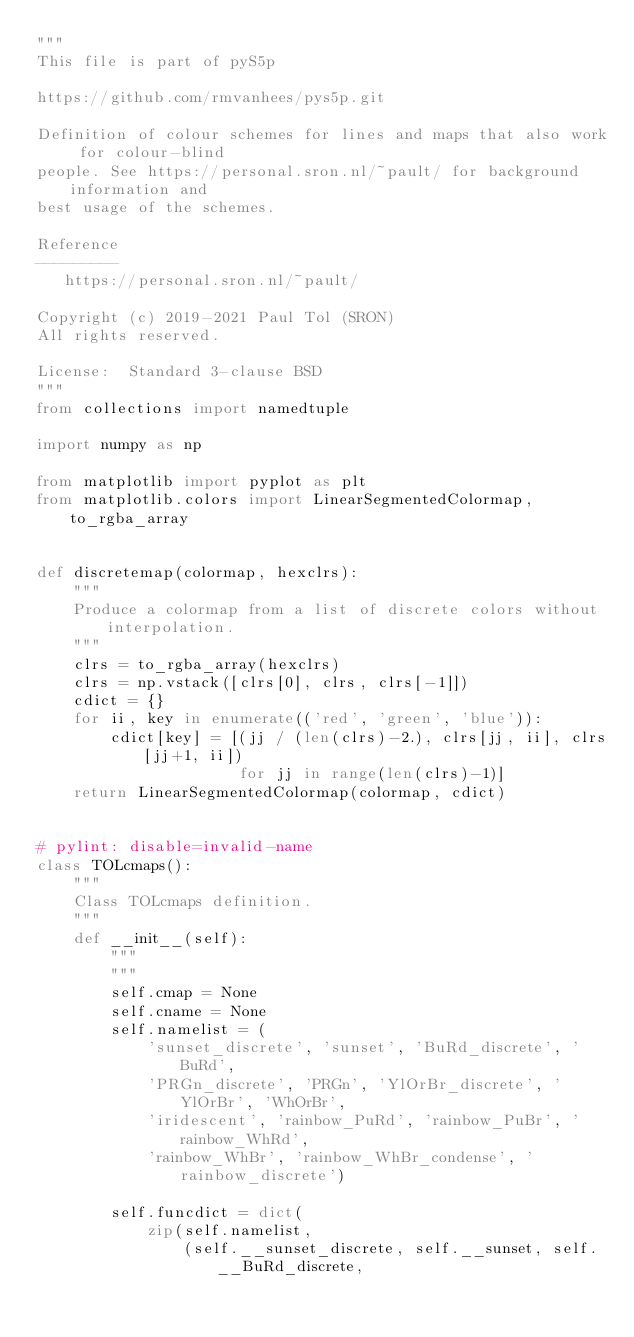Convert code to text. <code><loc_0><loc_0><loc_500><loc_500><_Python_>"""
This file is part of pyS5p

https://github.com/rmvanhees/pys5p.git

Definition of colour schemes for lines and maps that also work for colour-blind
people. See https://personal.sron.nl/~pault/ for background information and
best usage of the schemes.

Reference
---------
   https://personal.sron.nl/~pault/

Copyright (c) 2019-2021 Paul Tol (SRON)
All rights reserved.

License:  Standard 3-clause BSD
"""
from collections import namedtuple

import numpy as np

from matplotlib import pyplot as plt
from matplotlib.colors import LinearSegmentedColormap, to_rgba_array


def discretemap(colormap, hexclrs):
    """
    Produce a colormap from a list of discrete colors without interpolation.
    """
    clrs = to_rgba_array(hexclrs)
    clrs = np.vstack([clrs[0], clrs, clrs[-1]])
    cdict = {}
    for ii, key in enumerate(('red', 'green', 'blue')):
        cdict[key] = [(jj / (len(clrs)-2.), clrs[jj, ii], clrs[jj+1, ii])
                      for jj in range(len(clrs)-1)]
    return LinearSegmentedColormap(colormap, cdict)


# pylint: disable=invalid-name
class TOLcmaps():
    """
    Class TOLcmaps definition.
    """
    def __init__(self):
        """
        """
        self.cmap = None
        self.cname = None
        self.namelist = (
            'sunset_discrete', 'sunset', 'BuRd_discrete', 'BuRd',
            'PRGn_discrete', 'PRGn', 'YlOrBr_discrete', 'YlOrBr', 'WhOrBr',
            'iridescent', 'rainbow_PuRd', 'rainbow_PuBr', 'rainbow_WhRd',
            'rainbow_WhBr', 'rainbow_WhBr_condense', 'rainbow_discrete')

        self.funcdict = dict(
            zip(self.namelist,
                (self.__sunset_discrete, self.__sunset, self.__BuRd_discrete,</code> 